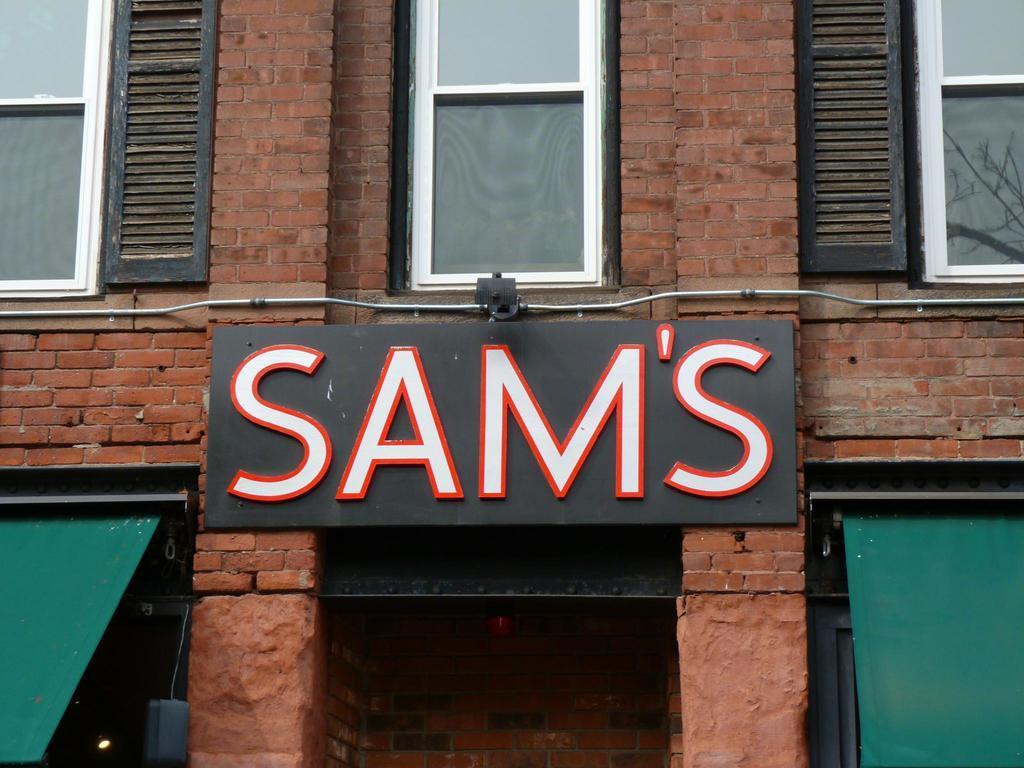Could you give a brief overview of what you see in this image? In this picture there is a board on the wall, beside that we can see the wires. At the top we can see windows, glass and brick wall. In the bottom right corner there is a green color cloth near to the blank door. 